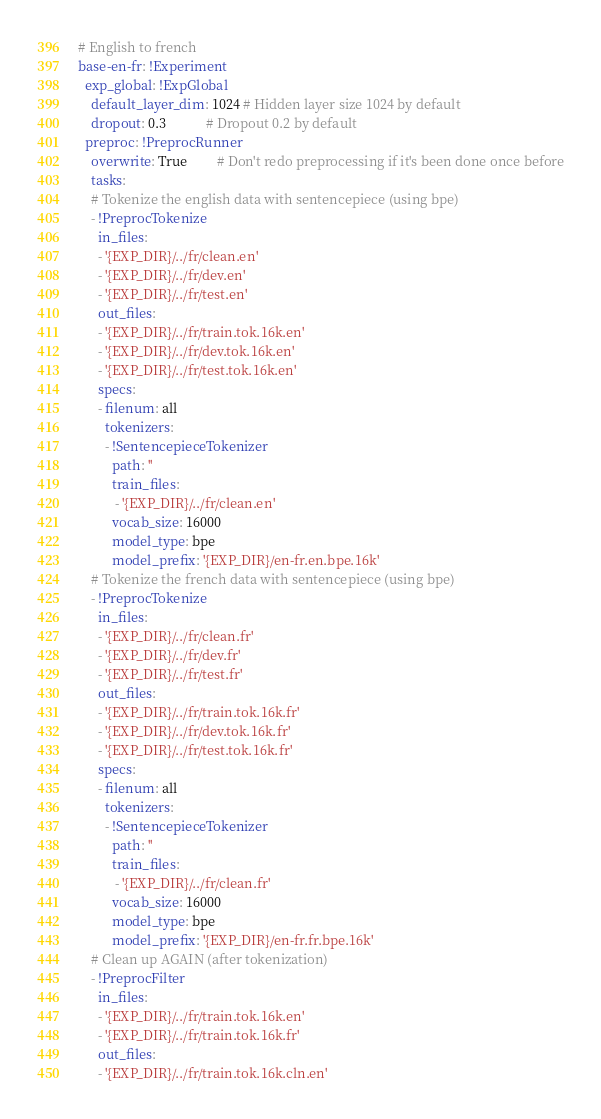<code> <loc_0><loc_0><loc_500><loc_500><_YAML_># English to french
base-en-fr: !Experiment
  exp_global: !ExpGlobal
    default_layer_dim: 1024 # Hidden layer size 1024 by default
    dropout: 0.3            # Dropout 0.2 by default
  preproc: !PreprocRunner
    overwrite: True         # Don't redo preprocessing if it's been done once before
    tasks:
    # Tokenize the english data with sentencepiece (using bpe)
    - !PreprocTokenize
      in_files:
      - '{EXP_DIR}/../fr/clean.en'
      - '{EXP_DIR}/../fr/dev.en'
      - '{EXP_DIR}/../fr/test.en'
      out_files:
      - '{EXP_DIR}/../fr/train.tok.16k.en'
      - '{EXP_DIR}/../fr/dev.tok.16k.en'
      - '{EXP_DIR}/../fr/test.tok.16k.en'
      specs:
      - filenum: all
        tokenizers:
        - !SentencepieceTokenizer
          path: ''
          train_files:
           - '{EXP_DIR}/../fr/clean.en'
          vocab_size: 16000
          model_type: bpe
          model_prefix: '{EXP_DIR}/en-fr.en.bpe.16k'
    # Tokenize the french data with sentencepiece (using bpe)
    - !PreprocTokenize
      in_files:
      - '{EXP_DIR}/../fr/clean.fr'
      - '{EXP_DIR}/../fr/dev.fr'
      - '{EXP_DIR}/../fr/test.fr'
      out_files:
      - '{EXP_DIR}/../fr/train.tok.16k.fr'
      - '{EXP_DIR}/../fr/dev.tok.16k.fr'
      - '{EXP_DIR}/../fr/test.tok.16k.fr'
      specs:
      - filenum: all
        tokenizers:
        - !SentencepieceTokenizer
          path: ''
          train_files:
           - '{EXP_DIR}/../fr/clean.fr'
          vocab_size: 16000
          model_type: bpe
          model_prefix: '{EXP_DIR}/en-fr.fr.bpe.16k'
    # Clean up AGAIN (after tokenization)
    - !PreprocFilter
      in_files:
      - '{EXP_DIR}/../fr/train.tok.16k.en'
      - '{EXP_DIR}/../fr/train.tok.16k.fr'
      out_files:
      - '{EXP_DIR}/../fr/train.tok.16k.cln.en'</code> 